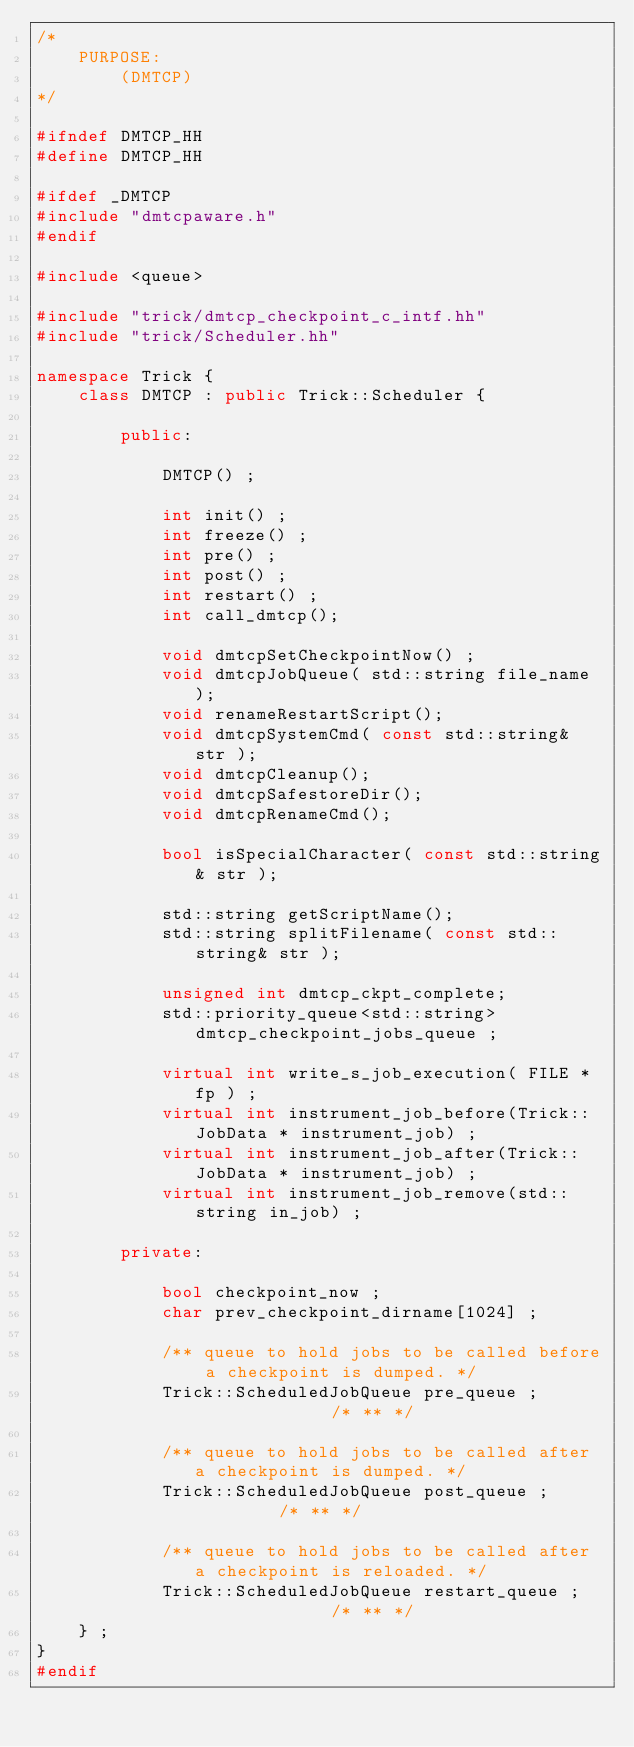Convert code to text. <code><loc_0><loc_0><loc_500><loc_500><_C++_>/*
    PURPOSE:
        (DMTCP)
*/

#ifndef DMTCP_HH
#define DMTCP_HH

#ifdef _DMTCP
#include "dmtcpaware.h"
#endif

#include <queue>

#include "trick/dmtcp_checkpoint_c_intf.hh"
#include "trick/Scheduler.hh"

namespace Trick {
    class DMTCP : public Trick::Scheduler {

        public:

            DMTCP() ;

            int init() ;
            int freeze() ;
            int pre() ;
            int post() ;
            int restart() ;
            int call_dmtcp();

            void dmtcpSetCheckpointNow() ;
            void dmtcpJobQueue( std::string file_name );
            void renameRestartScript();
            void dmtcpSystemCmd( const std::string& str );
            void dmtcpCleanup();
            void dmtcpSafestoreDir();
            void dmtcpRenameCmd();            

            bool isSpecialCharacter( const std::string& str );

            std::string getScriptName();
            std::string splitFilename( const std::string& str );

            unsigned int dmtcp_ckpt_complete;
            std::priority_queue<std::string> dmtcp_checkpoint_jobs_queue ;

            virtual int write_s_job_execution( FILE * fp ) ;
            virtual int instrument_job_before(Trick::JobData * instrument_job) ;
            virtual int instrument_job_after(Trick::JobData * instrument_job) ;
            virtual int instrument_job_remove(std::string in_job) ;

        private:

            bool checkpoint_now ;
            char prev_checkpoint_dirname[1024] ;

            /** queue to hold jobs to be called before a checkpoint is dumped. */
            Trick::ScheduledJobQueue pre_queue ;              /* ** */

            /** queue to hold jobs to be called after a checkpoint is dumped. */
            Trick::ScheduledJobQueue post_queue ;         /* ** */

            /** queue to hold jobs to be called after a checkpoint is reloaded. */
            Trick::ScheduledJobQueue restart_queue ;              /* ** */
    } ;
}
#endif
</code> 